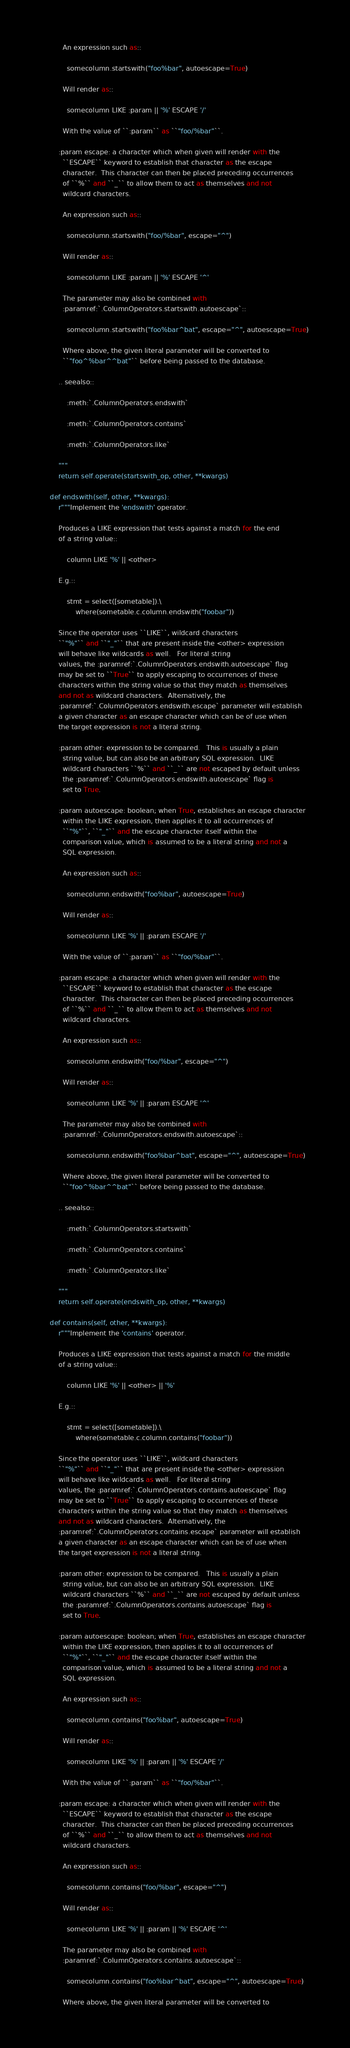Convert code to text. <code><loc_0><loc_0><loc_500><loc_500><_Python_>
          An expression such as::

            somecolumn.startswith("foo%bar", autoescape=True)

          Will render as::

            somecolumn LIKE :param || '%' ESCAPE '/'

          With the value of ``:param`` as ``"foo/%bar"``.

        :param escape: a character which when given will render with the
          ``ESCAPE`` keyword to establish that character as the escape
          character.  This character can then be placed preceding occurrences
          of ``%`` and ``_`` to allow them to act as themselves and not
          wildcard characters.

          An expression such as::

            somecolumn.startswith("foo/%bar", escape="^")

          Will render as::

            somecolumn LIKE :param || '%' ESCAPE '^'

          The parameter may also be combined with
          :paramref:`.ColumnOperators.startswith.autoescape`::

            somecolumn.startswith("foo%bar^bat", escape="^", autoescape=True)

          Where above, the given literal parameter will be converted to
          ``"foo^%bar^^bat"`` before being passed to the database.

        .. seealso::

            :meth:`.ColumnOperators.endswith`

            :meth:`.ColumnOperators.contains`

            :meth:`.ColumnOperators.like`

        """
        return self.operate(startswith_op, other, **kwargs)

    def endswith(self, other, **kwargs):
        r"""Implement the 'endswith' operator.

        Produces a LIKE expression that tests against a match for the end
        of a string value::

            column LIKE '%' || <other>

        E.g.::

            stmt = select([sometable]).\
                where(sometable.c.column.endswith("foobar"))

        Since the operator uses ``LIKE``, wildcard characters
        ``"%"`` and ``"_"`` that are present inside the <other> expression
        will behave like wildcards as well.   For literal string
        values, the :paramref:`.ColumnOperators.endswith.autoescape` flag
        may be set to ``True`` to apply escaping to occurrences of these
        characters within the string value so that they match as themselves
        and not as wildcard characters.  Alternatively, the
        :paramref:`.ColumnOperators.endswith.escape` parameter will establish
        a given character as an escape character which can be of use when
        the target expression is not a literal string.

        :param other: expression to be compared.   This is usually a plain
          string value, but can also be an arbitrary SQL expression.  LIKE
          wildcard characters ``%`` and ``_`` are not escaped by default unless
          the :paramref:`.ColumnOperators.endswith.autoescape` flag is
          set to True.

        :param autoescape: boolean; when True, establishes an escape character
          within the LIKE expression, then applies it to all occurrences of
          ``"%"``, ``"_"`` and the escape character itself within the
          comparison value, which is assumed to be a literal string and not a
          SQL expression.

          An expression such as::

            somecolumn.endswith("foo%bar", autoescape=True)

          Will render as::

            somecolumn LIKE '%' || :param ESCAPE '/'

          With the value of ``:param`` as ``"foo/%bar"``.

        :param escape: a character which when given will render with the
          ``ESCAPE`` keyword to establish that character as the escape
          character.  This character can then be placed preceding occurrences
          of ``%`` and ``_`` to allow them to act as themselves and not
          wildcard characters.

          An expression such as::

            somecolumn.endswith("foo/%bar", escape="^")

          Will render as::

            somecolumn LIKE '%' || :param ESCAPE '^'

          The parameter may also be combined with
          :paramref:`.ColumnOperators.endswith.autoescape`::

            somecolumn.endswith("foo%bar^bat", escape="^", autoescape=True)

          Where above, the given literal parameter will be converted to
          ``"foo^%bar^^bat"`` before being passed to the database.

        .. seealso::

            :meth:`.ColumnOperators.startswith`

            :meth:`.ColumnOperators.contains`

            :meth:`.ColumnOperators.like`

        """
        return self.operate(endswith_op, other, **kwargs)

    def contains(self, other, **kwargs):
        r"""Implement the 'contains' operator.

        Produces a LIKE expression that tests against a match for the middle
        of a string value::

            column LIKE '%' || <other> || '%'

        E.g.::

            stmt = select([sometable]).\
                where(sometable.c.column.contains("foobar"))

        Since the operator uses ``LIKE``, wildcard characters
        ``"%"`` and ``"_"`` that are present inside the <other> expression
        will behave like wildcards as well.   For literal string
        values, the :paramref:`.ColumnOperators.contains.autoescape` flag
        may be set to ``True`` to apply escaping to occurrences of these
        characters within the string value so that they match as themselves
        and not as wildcard characters.  Alternatively, the
        :paramref:`.ColumnOperators.contains.escape` parameter will establish
        a given character as an escape character which can be of use when
        the target expression is not a literal string.

        :param other: expression to be compared.   This is usually a plain
          string value, but can also be an arbitrary SQL expression.  LIKE
          wildcard characters ``%`` and ``_`` are not escaped by default unless
          the :paramref:`.ColumnOperators.contains.autoescape` flag is
          set to True.

        :param autoescape: boolean; when True, establishes an escape character
          within the LIKE expression, then applies it to all occurrences of
          ``"%"``, ``"_"`` and the escape character itself within the
          comparison value, which is assumed to be a literal string and not a
          SQL expression.

          An expression such as::

            somecolumn.contains("foo%bar", autoescape=True)

          Will render as::

            somecolumn LIKE '%' || :param || '%' ESCAPE '/'

          With the value of ``:param`` as ``"foo/%bar"``.

        :param escape: a character which when given will render with the
          ``ESCAPE`` keyword to establish that character as the escape
          character.  This character can then be placed preceding occurrences
          of ``%`` and ``_`` to allow them to act as themselves and not
          wildcard characters.

          An expression such as::

            somecolumn.contains("foo/%bar", escape="^")

          Will render as::

            somecolumn LIKE '%' || :param || '%' ESCAPE '^'

          The parameter may also be combined with
          :paramref:`.ColumnOperators.contains.autoescape`::

            somecolumn.contains("foo%bar^bat", escape="^", autoescape=True)

          Where above, the given literal parameter will be converted to</code> 